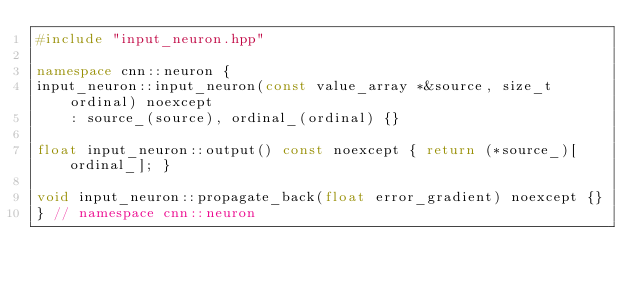Convert code to text. <code><loc_0><loc_0><loc_500><loc_500><_C++_>#include "input_neuron.hpp"

namespace cnn::neuron {
input_neuron::input_neuron(const value_array *&source, size_t ordinal) noexcept
    : source_(source), ordinal_(ordinal) {}

float input_neuron::output() const noexcept { return (*source_)[ordinal_]; }

void input_neuron::propagate_back(float error_gradient) noexcept {}
} // namespace cnn::neuron</code> 